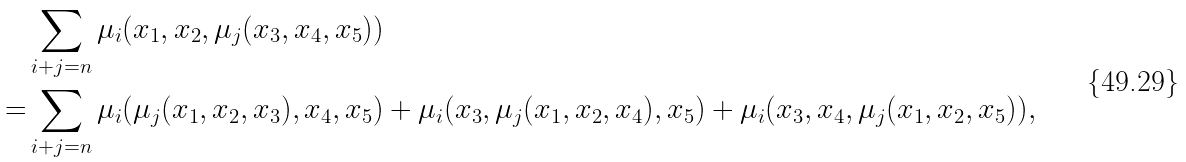<formula> <loc_0><loc_0><loc_500><loc_500>& \sum _ { i + j = n } \mu _ { i } ( x _ { 1 } , x _ { 2 } , \mu _ { j } ( x _ { 3 } , x _ { 4 } , x _ { 5 } ) ) \\ = & \sum _ { i + j = n } \mu _ { i } ( \mu _ { j } ( x _ { 1 } , x _ { 2 } , x _ { 3 } ) , x _ { 4 } , x _ { 5 } ) + \mu _ { i } ( x _ { 3 } , \mu _ { j } ( x _ { 1 } , x _ { 2 } , x _ { 4 } ) , x _ { 5 } ) + \mu _ { i } ( x _ { 3 } , x _ { 4 } , \mu _ { j } ( x _ { 1 } , x _ { 2 } , x _ { 5 } ) ) ,</formula> 